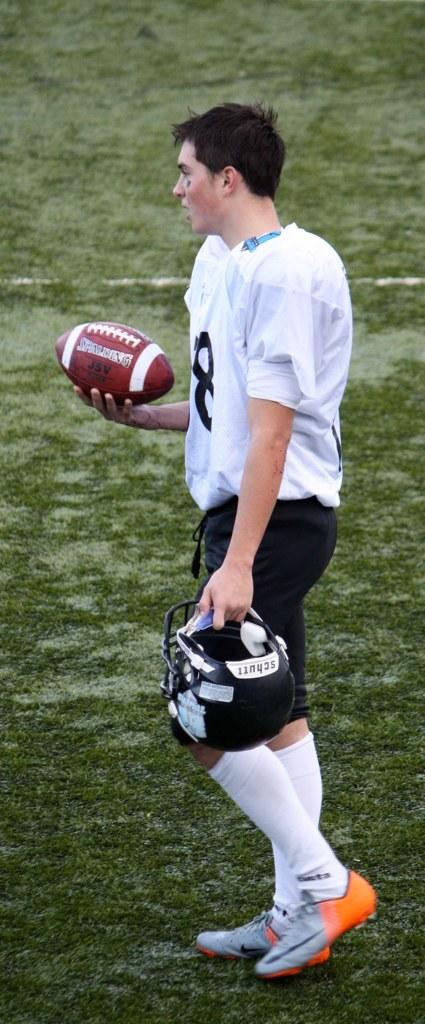What is the main subject of the picture? The main subject of the picture is a man. What is the man holding in one hand? The man is holding a helmet in one hand. What is the man holding in the other hand? The man is holding a rugby ball in the other hand. What type of surface is visible in the image? There is grass on the ground in the image. Can you tell me how many kittens are playing on the road in the image? There are no kittens or roads present in the image; it features a man holding a helmet and a rugby ball on a grassy surface. 